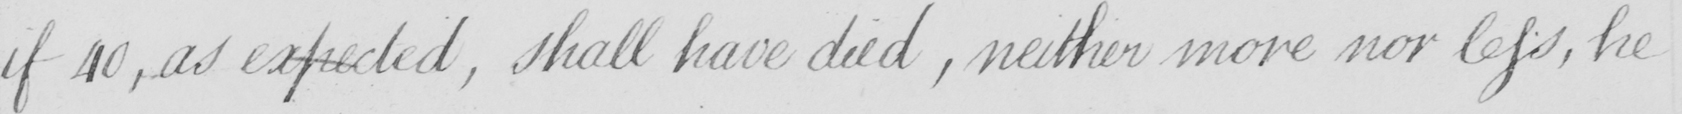What is written in this line of handwriting? if 40 , as expected , shall have died , neither more nor less , he 